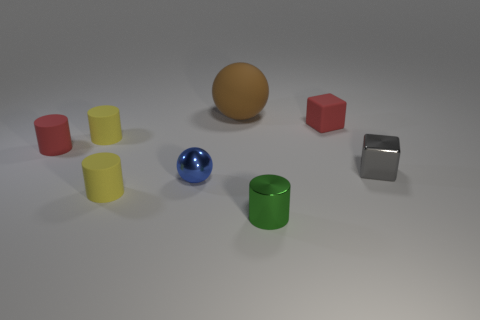Subtract 2 cylinders. How many cylinders are left? 2 Subtract all green cylinders. How many cylinders are left? 3 Subtract all blue cylinders. Subtract all blue cubes. How many cylinders are left? 4 Add 2 tiny yellow matte cylinders. How many objects exist? 10 Subtract all spheres. How many objects are left? 6 Add 2 tiny green cylinders. How many tiny green cylinders exist? 3 Subtract 1 red cubes. How many objects are left? 7 Subtract all red rubber cylinders. Subtract all yellow matte objects. How many objects are left? 5 Add 6 shiny cylinders. How many shiny cylinders are left? 7 